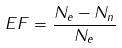<formula> <loc_0><loc_0><loc_500><loc_500>E F = \frac { N _ { e } - N _ { n } } { N _ { e } }</formula> 